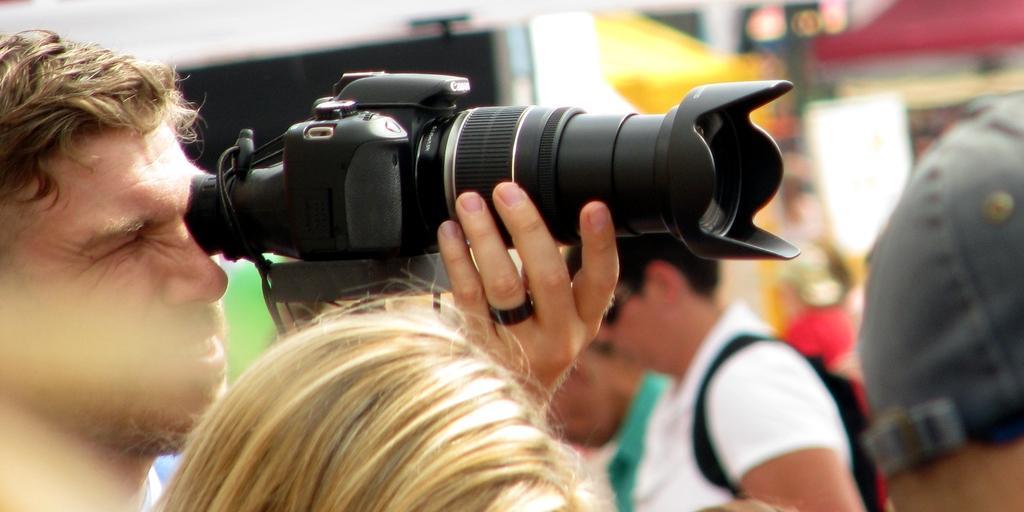In one or two sentences, can you explain what this image depicts? In the image there are group of people. On left side there is a man who is holding a camera, on right side there is a man wearing his hat we can also see another man wearing his backpack and also wearing his goggles. 